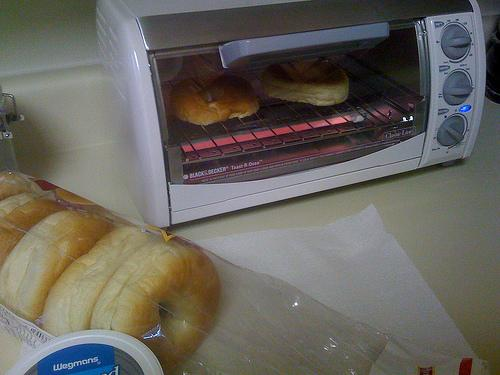State the number of bagels available in the image and how they are arranged. There are five bagels, with two inside the toaster oven and the rest in a plastic bag. In a brief sentence, describe the key elements of this image. A toaster oven is in the process of toasting bagels, while a bag of un-toasted bagels sits nearby. Is there any indication that the bagels in the image may be intended for a specific brand, and if so, which brand? Yes, there is a Wegmans cover label, suggesting the bagels are from Wegmans. Identify the type of surface on which the toaster oven is placed. The toaster oven is placed on a countertop. Point out the kitchen appliance seen in the image and mention its color. There is a white Black & Decker toaster oven on the countertop. Mention any visible brand name associated with the toaster oven in the image. The toaster oven is a Black & Decker model. What color are the knobs on the toaster oven, and how many knobs are there? The knobs are gray, and there are three of them. What kind of food item can be seen in the image and in what state are they? Bagels are visible in the image, and they are being toasted in the toaster oven. Describe any distinct element in the toaster oven that may indicate it is working. The toaster oven has red hot coils, indicating it is in operation. Identify the material of the napkin seen in the image and its color. The napkin is made of white waxed paper. 